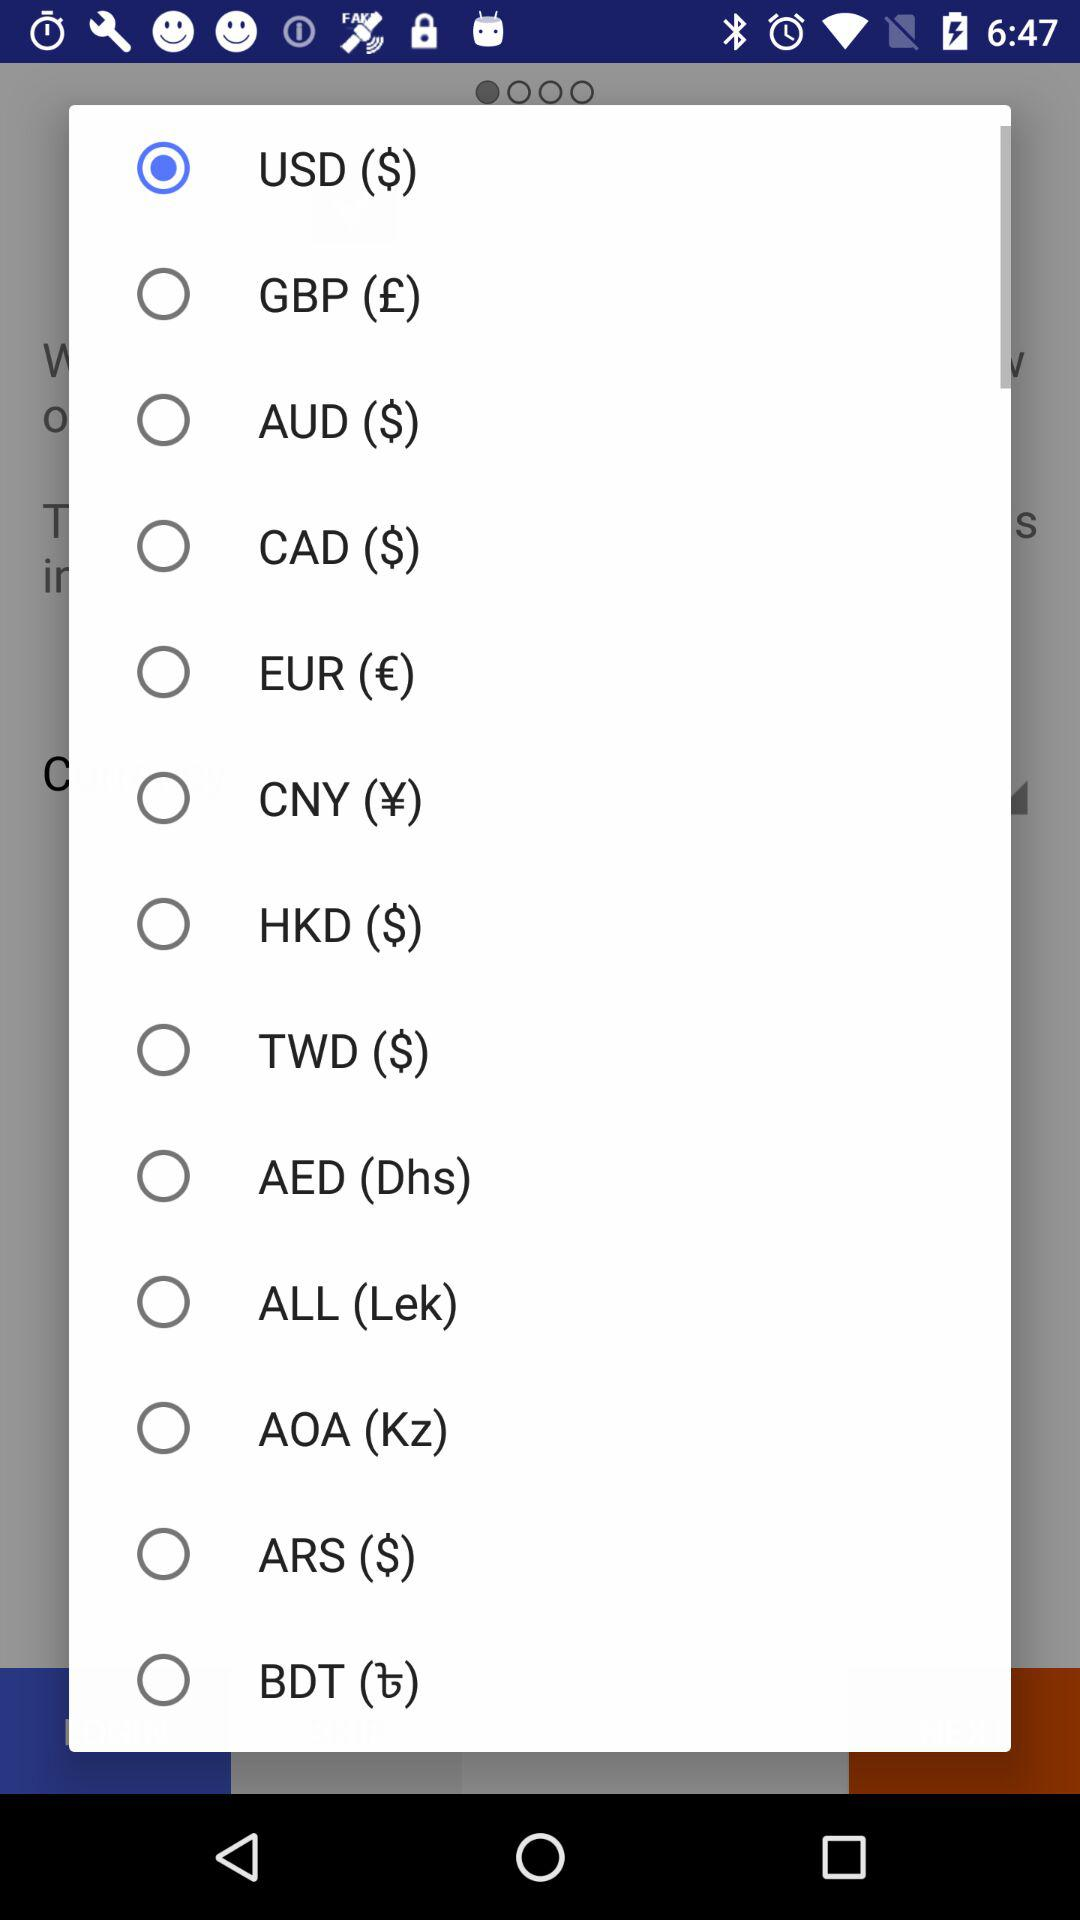What are the different currencies displayed in the list? The different currencies displayed in the list are USD, GBP, AUD, CAD, EUR, CNY, HKD, TWD, AED, ALL, AOA, ARS and BDT. 